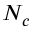Convert formula to latex. <formula><loc_0><loc_0><loc_500><loc_500>N _ { c }</formula> 